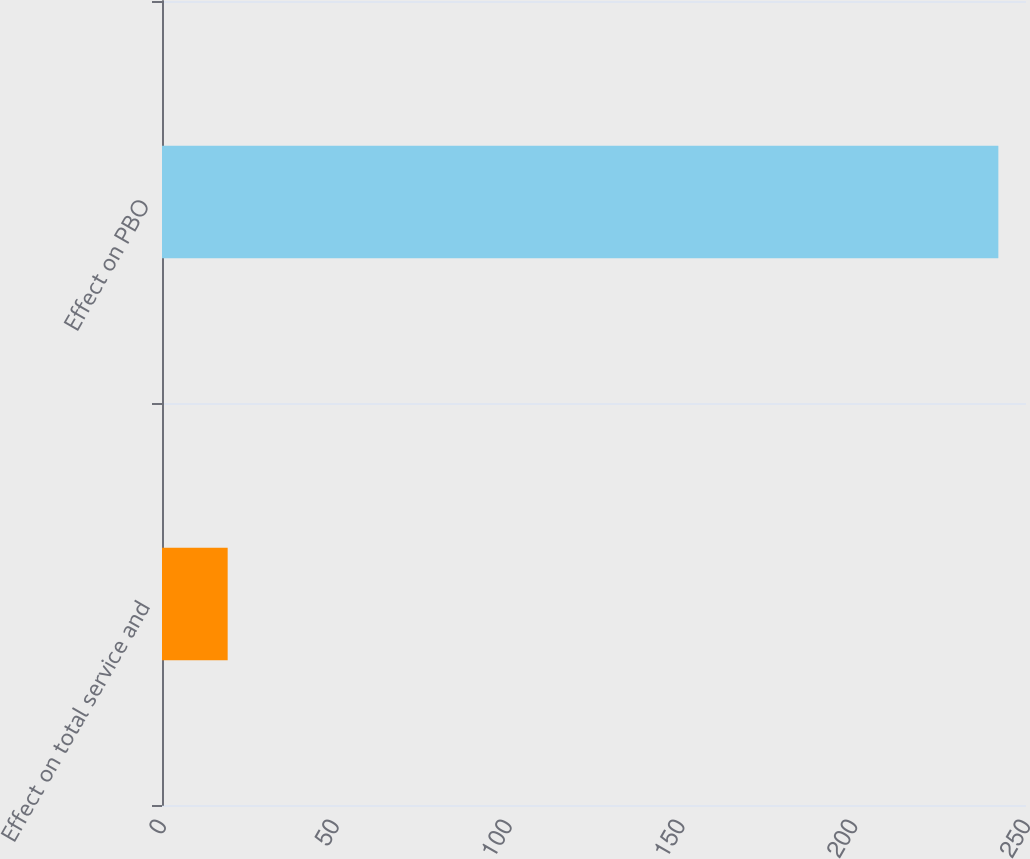Convert chart. <chart><loc_0><loc_0><loc_500><loc_500><bar_chart><fcel>Effect on total service and<fcel>Effect on PBO<nl><fcel>19<fcel>242<nl></chart> 